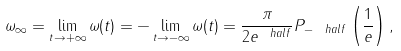<formula> <loc_0><loc_0><loc_500><loc_500>\omega _ { \infty } = \lim _ { t \rightarrow + \infty } \omega ( t ) = - \lim _ { t \rightarrow - \infty } \omega ( t ) = \frac { \pi } { 2 e ^ { \ h a l f } } P _ { - \ h a l f } \left ( \frac { 1 } { e } \right ) ,</formula> 